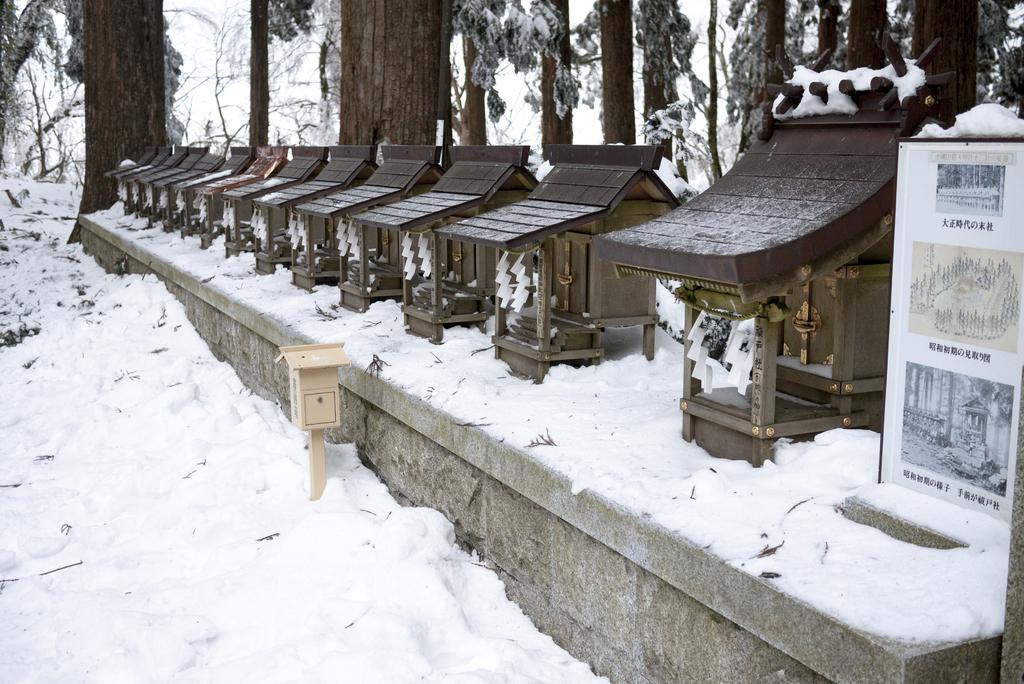In one or two sentences, can you explain what this image depicts? In this image there is a snow floor in the bottom of this image and there are some wooden objects are kept in middle of this image and there are some trees in the background. There is one board kept on the right side of this image. there is one object kept in the bottom of this image. 